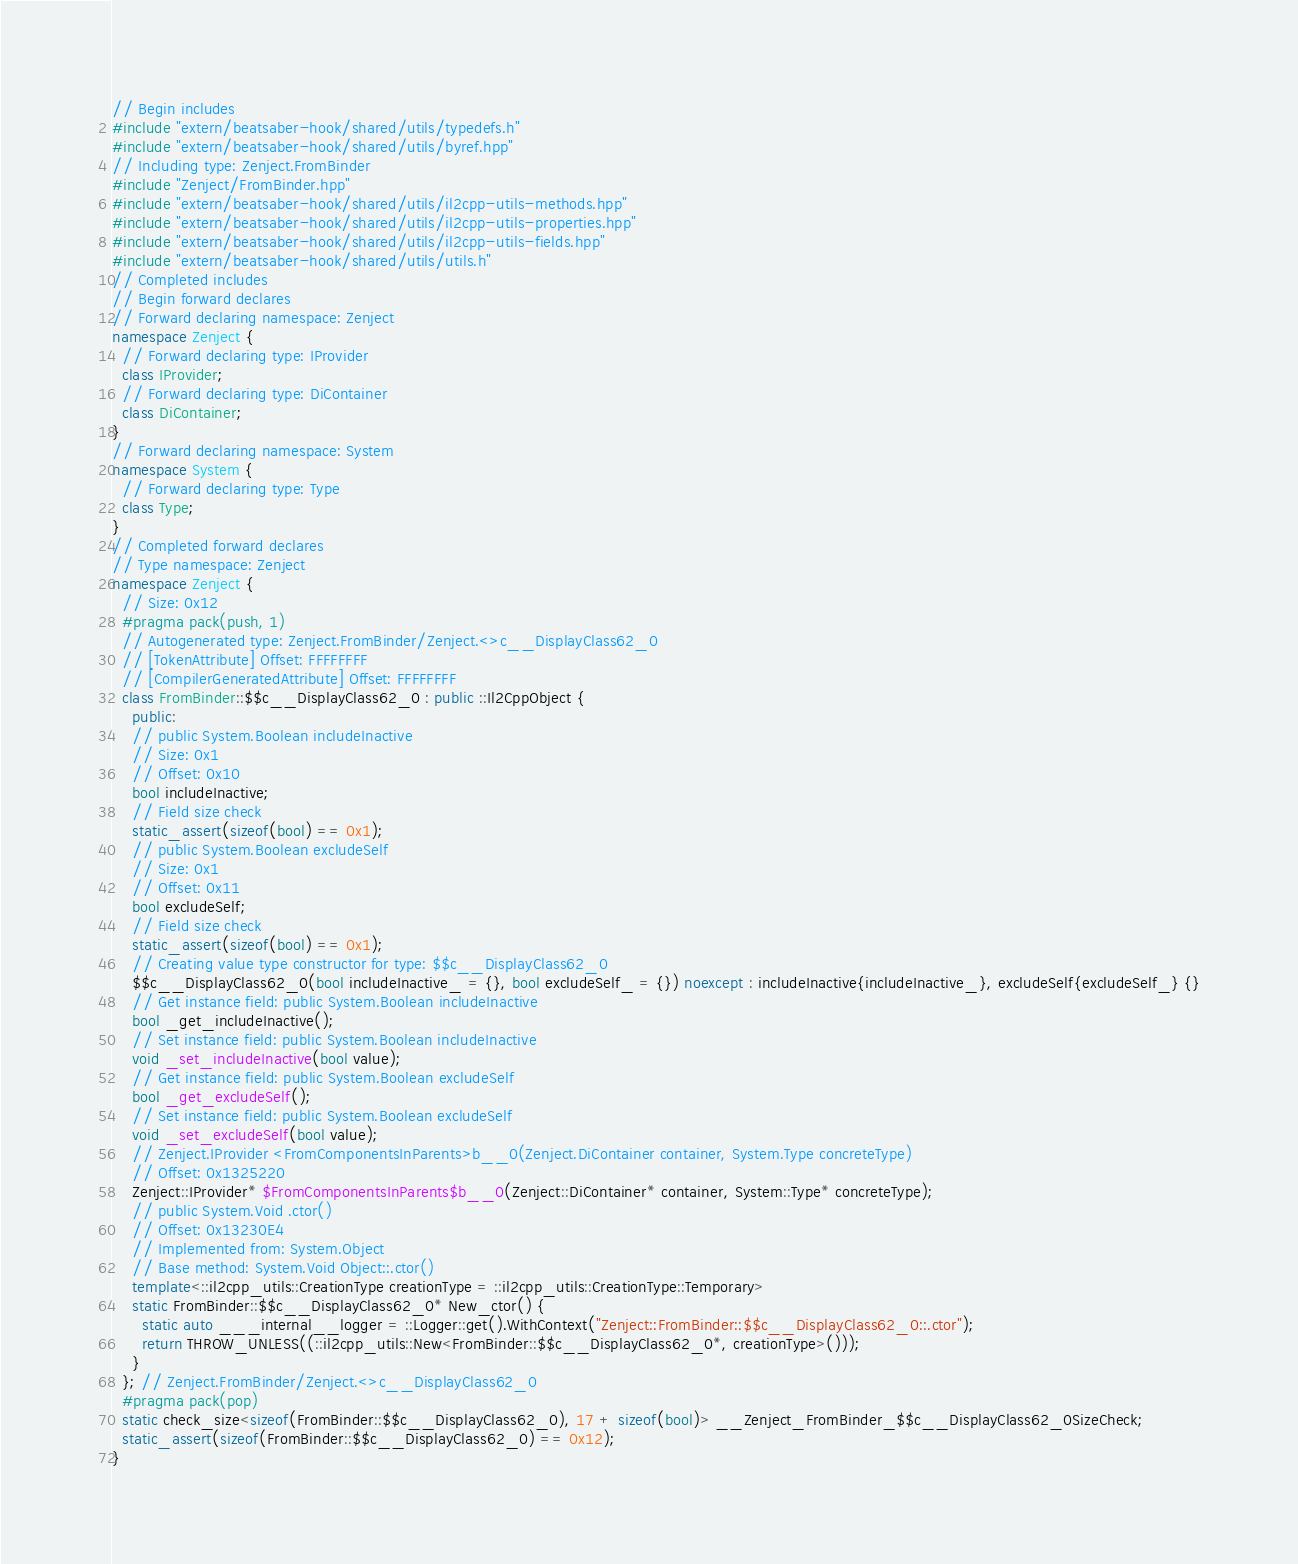Convert code to text. <code><loc_0><loc_0><loc_500><loc_500><_C++_>// Begin includes
#include "extern/beatsaber-hook/shared/utils/typedefs.h"
#include "extern/beatsaber-hook/shared/utils/byref.hpp"
// Including type: Zenject.FromBinder
#include "Zenject/FromBinder.hpp"
#include "extern/beatsaber-hook/shared/utils/il2cpp-utils-methods.hpp"
#include "extern/beatsaber-hook/shared/utils/il2cpp-utils-properties.hpp"
#include "extern/beatsaber-hook/shared/utils/il2cpp-utils-fields.hpp"
#include "extern/beatsaber-hook/shared/utils/utils.h"
// Completed includes
// Begin forward declares
// Forward declaring namespace: Zenject
namespace Zenject {
  // Forward declaring type: IProvider
  class IProvider;
  // Forward declaring type: DiContainer
  class DiContainer;
}
// Forward declaring namespace: System
namespace System {
  // Forward declaring type: Type
  class Type;
}
// Completed forward declares
// Type namespace: Zenject
namespace Zenject {
  // Size: 0x12
  #pragma pack(push, 1)
  // Autogenerated type: Zenject.FromBinder/Zenject.<>c__DisplayClass62_0
  // [TokenAttribute] Offset: FFFFFFFF
  // [CompilerGeneratedAttribute] Offset: FFFFFFFF
  class FromBinder::$$c__DisplayClass62_0 : public ::Il2CppObject {
    public:
    // public System.Boolean includeInactive
    // Size: 0x1
    // Offset: 0x10
    bool includeInactive;
    // Field size check
    static_assert(sizeof(bool) == 0x1);
    // public System.Boolean excludeSelf
    // Size: 0x1
    // Offset: 0x11
    bool excludeSelf;
    // Field size check
    static_assert(sizeof(bool) == 0x1);
    // Creating value type constructor for type: $$c__DisplayClass62_0
    $$c__DisplayClass62_0(bool includeInactive_ = {}, bool excludeSelf_ = {}) noexcept : includeInactive{includeInactive_}, excludeSelf{excludeSelf_} {}
    // Get instance field: public System.Boolean includeInactive
    bool _get_includeInactive();
    // Set instance field: public System.Boolean includeInactive
    void _set_includeInactive(bool value);
    // Get instance field: public System.Boolean excludeSelf
    bool _get_excludeSelf();
    // Set instance field: public System.Boolean excludeSelf
    void _set_excludeSelf(bool value);
    // Zenject.IProvider <FromComponentsInParents>b__0(Zenject.DiContainer container, System.Type concreteType)
    // Offset: 0x1325220
    Zenject::IProvider* $FromComponentsInParents$b__0(Zenject::DiContainer* container, System::Type* concreteType);
    // public System.Void .ctor()
    // Offset: 0x13230E4
    // Implemented from: System.Object
    // Base method: System.Void Object::.ctor()
    template<::il2cpp_utils::CreationType creationType = ::il2cpp_utils::CreationType::Temporary>
    static FromBinder::$$c__DisplayClass62_0* New_ctor() {
      static auto ___internal__logger = ::Logger::get().WithContext("Zenject::FromBinder::$$c__DisplayClass62_0::.ctor");
      return THROW_UNLESS((::il2cpp_utils::New<FromBinder::$$c__DisplayClass62_0*, creationType>()));
    }
  }; // Zenject.FromBinder/Zenject.<>c__DisplayClass62_0
  #pragma pack(pop)
  static check_size<sizeof(FromBinder::$$c__DisplayClass62_0), 17 + sizeof(bool)> __Zenject_FromBinder_$$c__DisplayClass62_0SizeCheck;
  static_assert(sizeof(FromBinder::$$c__DisplayClass62_0) == 0x12);
}</code> 